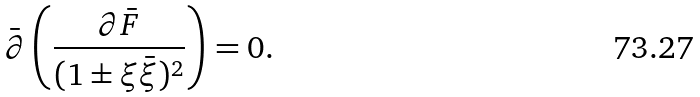<formula> <loc_0><loc_0><loc_500><loc_500>\bar { \partial } \left ( \frac { \partial \bar { F } } { ( 1 \pm \xi \bar { \xi } ) ^ { 2 } } \right ) = 0 .</formula> 